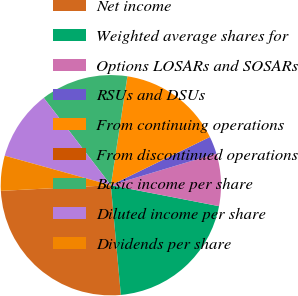Convert chart to OTSL. <chart><loc_0><loc_0><loc_500><loc_500><pie_chart><fcel>Net income<fcel>Weighted average shares for<fcel>Options LOSARs and SOSARs<fcel>RSUs and DSUs<fcel>From continuing operations<fcel>From discontinued operations<fcel>Basic income per share<fcel>Diluted income per share<fcel>Dividends per share<nl><fcel>25.63%<fcel>20.51%<fcel>7.69%<fcel>2.57%<fcel>15.38%<fcel>0.01%<fcel>12.82%<fcel>10.26%<fcel>5.13%<nl></chart> 